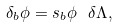Convert formula to latex. <formula><loc_0><loc_0><loc_500><loc_500>\delta _ { b } \phi = s _ { b } \phi \ \delta \Lambda ,</formula> 